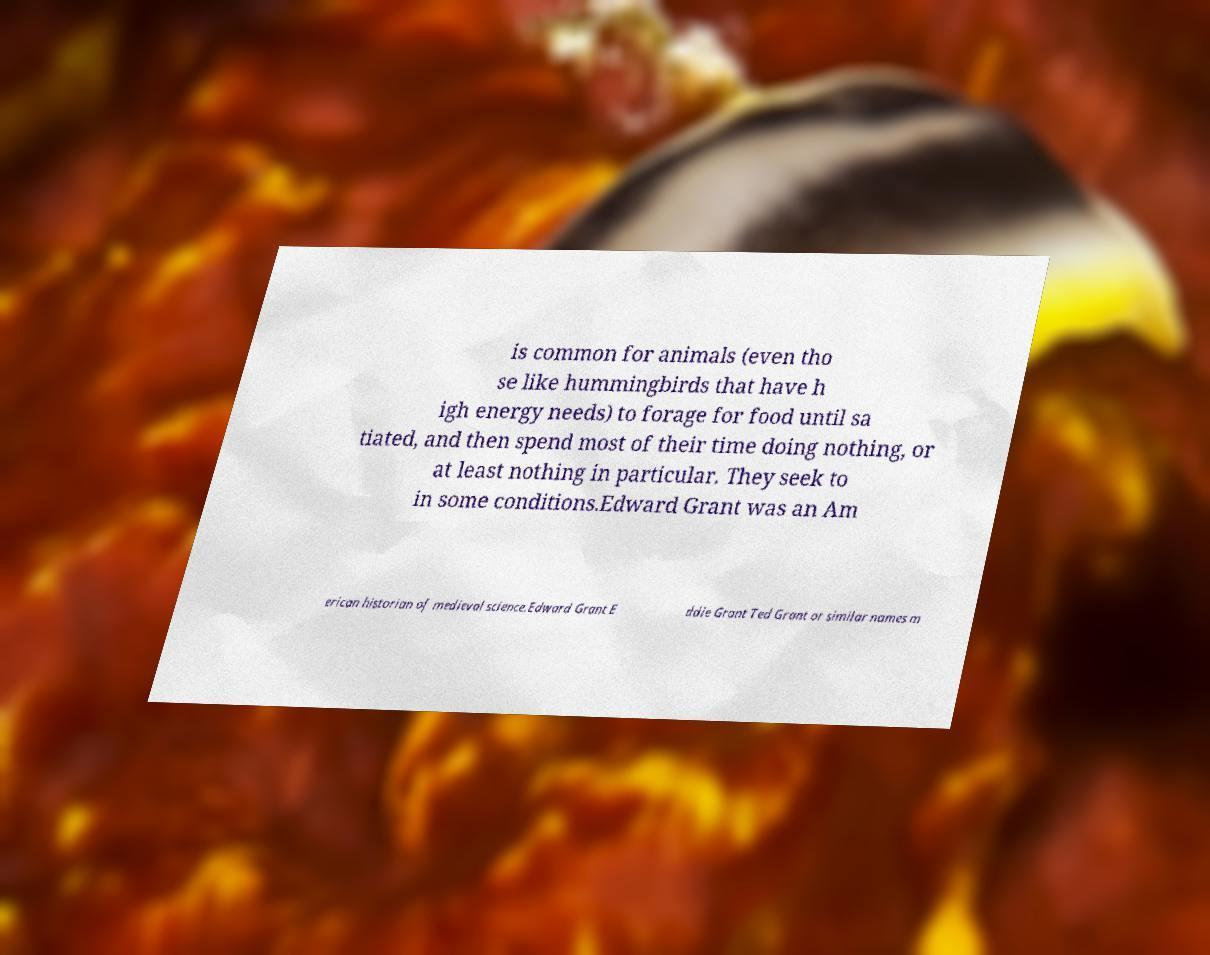Could you assist in decoding the text presented in this image and type it out clearly? is common for animals (even tho se like hummingbirds that have h igh energy needs) to forage for food until sa tiated, and then spend most of their time doing nothing, or at least nothing in particular. They seek to in some conditions.Edward Grant was an Am erican historian of medieval science.Edward Grant E ddie Grant Ted Grant or similar names m 